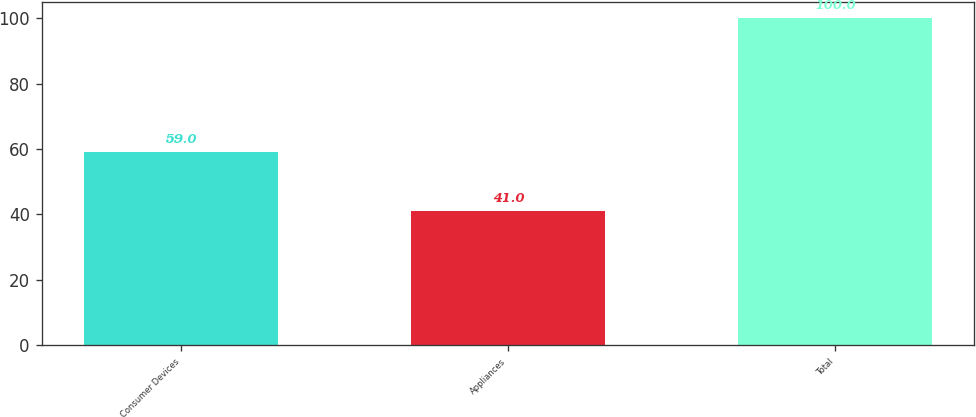<chart> <loc_0><loc_0><loc_500><loc_500><bar_chart><fcel>Consumer Devices<fcel>Appliances<fcel>Total<nl><fcel>59<fcel>41<fcel>100<nl></chart> 